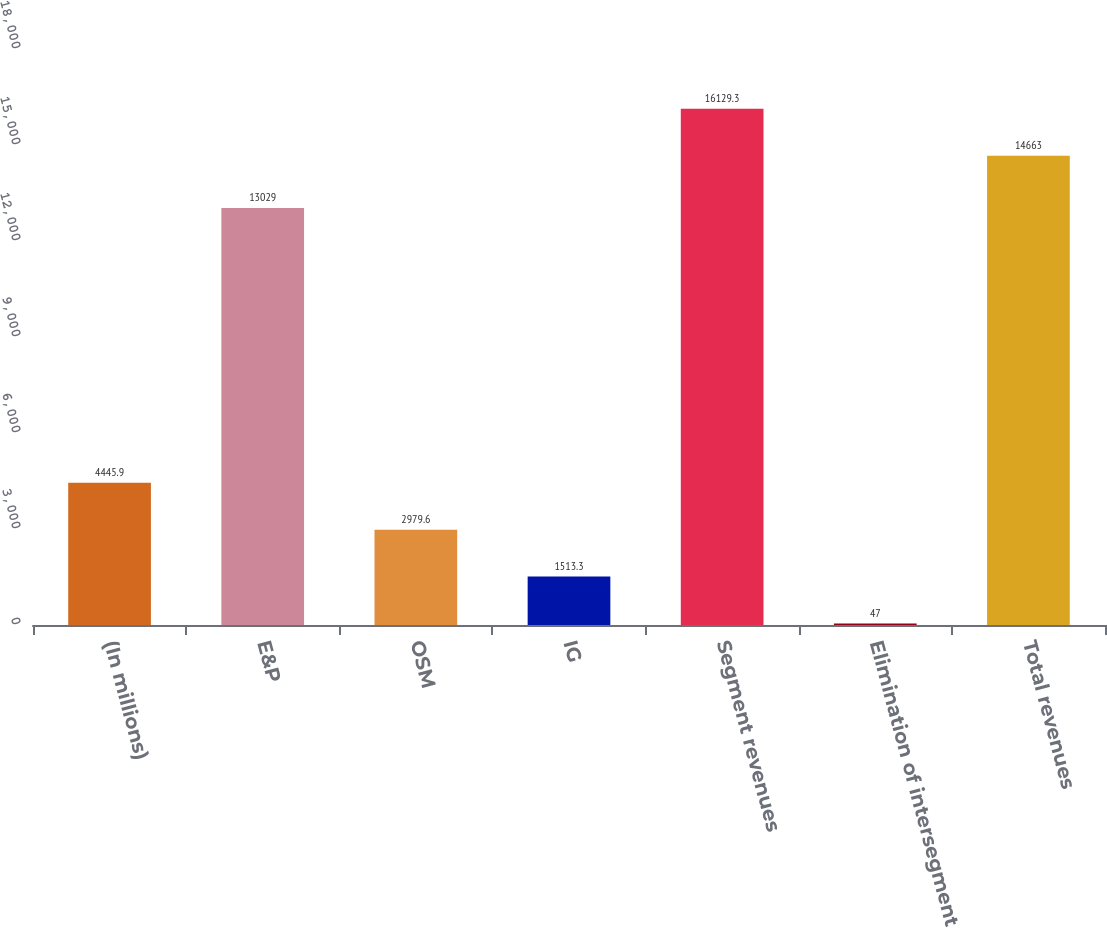Convert chart to OTSL. <chart><loc_0><loc_0><loc_500><loc_500><bar_chart><fcel>(In millions)<fcel>E&P<fcel>OSM<fcel>IG<fcel>Segment revenues<fcel>Elimination of intersegment<fcel>Total revenues<nl><fcel>4445.9<fcel>13029<fcel>2979.6<fcel>1513.3<fcel>16129.3<fcel>47<fcel>14663<nl></chart> 